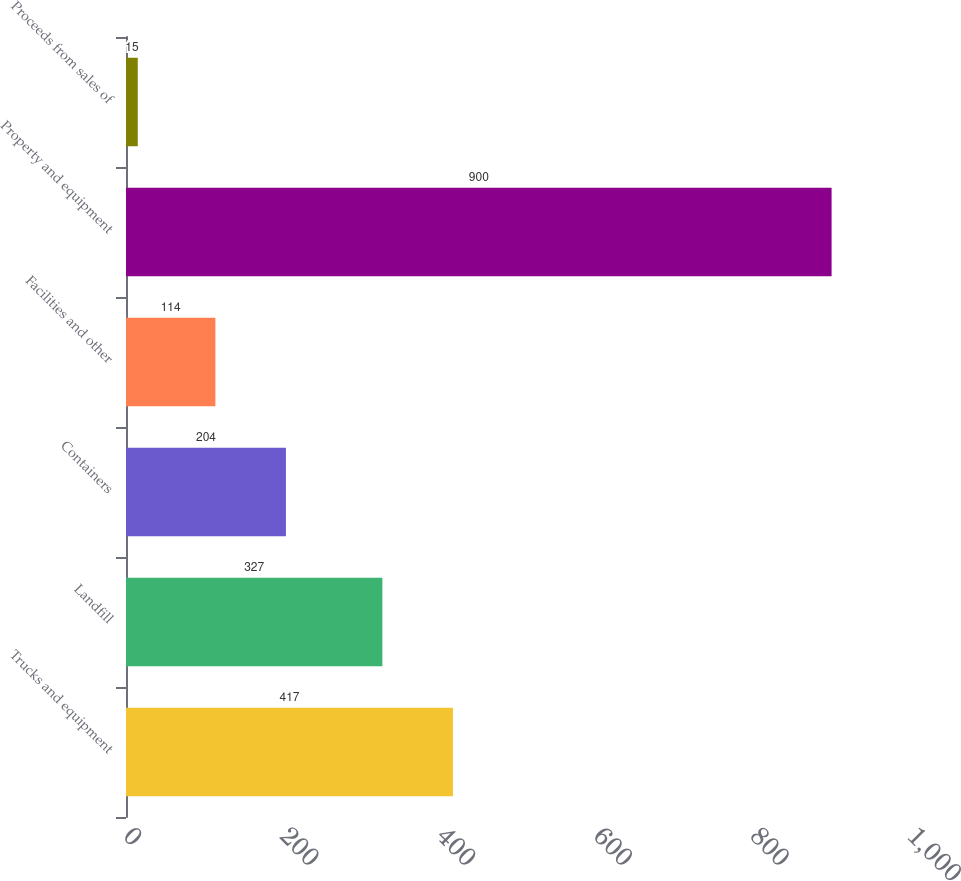Convert chart to OTSL. <chart><loc_0><loc_0><loc_500><loc_500><bar_chart><fcel>Trucks and equipment<fcel>Landfill<fcel>Containers<fcel>Facilities and other<fcel>Property and equipment<fcel>Proceeds from sales of<nl><fcel>417<fcel>327<fcel>204<fcel>114<fcel>900<fcel>15<nl></chart> 